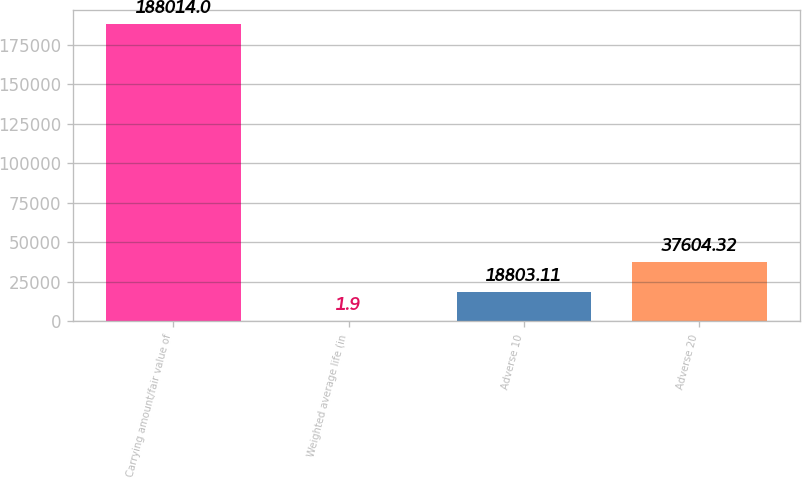Convert chart. <chart><loc_0><loc_0><loc_500><loc_500><bar_chart><fcel>Carrying amount/fair value of<fcel>Weighted average life (in<fcel>Adverse 10<fcel>Adverse 20<nl><fcel>188014<fcel>1.9<fcel>18803.1<fcel>37604.3<nl></chart> 